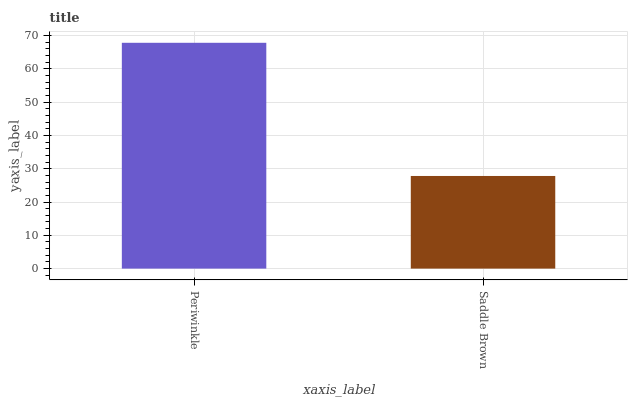Is Saddle Brown the minimum?
Answer yes or no. Yes. Is Periwinkle the maximum?
Answer yes or no. Yes. Is Saddle Brown the maximum?
Answer yes or no. No. Is Periwinkle greater than Saddle Brown?
Answer yes or no. Yes. Is Saddle Brown less than Periwinkle?
Answer yes or no. Yes. Is Saddle Brown greater than Periwinkle?
Answer yes or no. No. Is Periwinkle less than Saddle Brown?
Answer yes or no. No. Is Periwinkle the high median?
Answer yes or no. Yes. Is Saddle Brown the low median?
Answer yes or no. Yes. Is Saddle Brown the high median?
Answer yes or no. No. Is Periwinkle the low median?
Answer yes or no. No. 